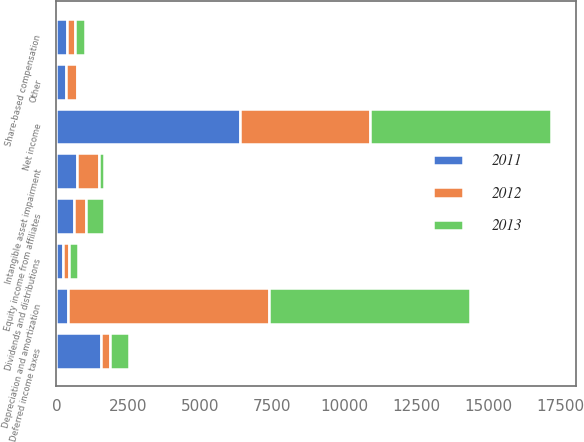<chart> <loc_0><loc_0><loc_500><loc_500><stacked_bar_chart><ecel><fcel>Net income<fcel>Depreciation and amortization<fcel>Intangible asset impairment<fcel>Equity income from affiliates<fcel>Dividends and distributions<fcel>Deferred income taxes<fcel>Share-based compensation<fcel>Other<nl><fcel>2012<fcel>4517<fcel>6988<fcel>765<fcel>404<fcel>237<fcel>330<fcel>276<fcel>399<nl><fcel>2013<fcel>6299<fcel>6978<fcel>200<fcel>642<fcel>291<fcel>669<fcel>335<fcel>28<nl><fcel>2011<fcel>6392<fcel>404<fcel>705<fcel>610<fcel>216<fcel>1537<fcel>369<fcel>323<nl></chart> 